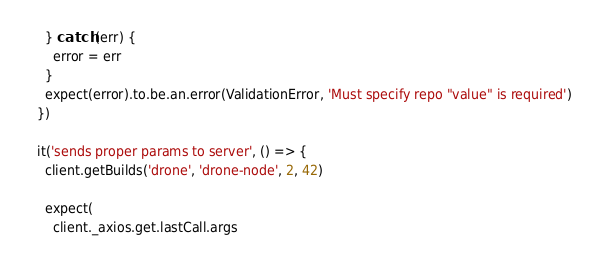Convert code to text. <code><loc_0><loc_0><loc_500><loc_500><_JavaScript_>    } catch (err) {
      error = err
    }
    expect(error).to.be.an.error(ValidationError, 'Must specify repo "value" is required')
  })

  it('sends proper params to server', () => {
    client.getBuilds('drone', 'drone-node', 2, 42)

    expect(
      client._axios.get.lastCall.args</code> 